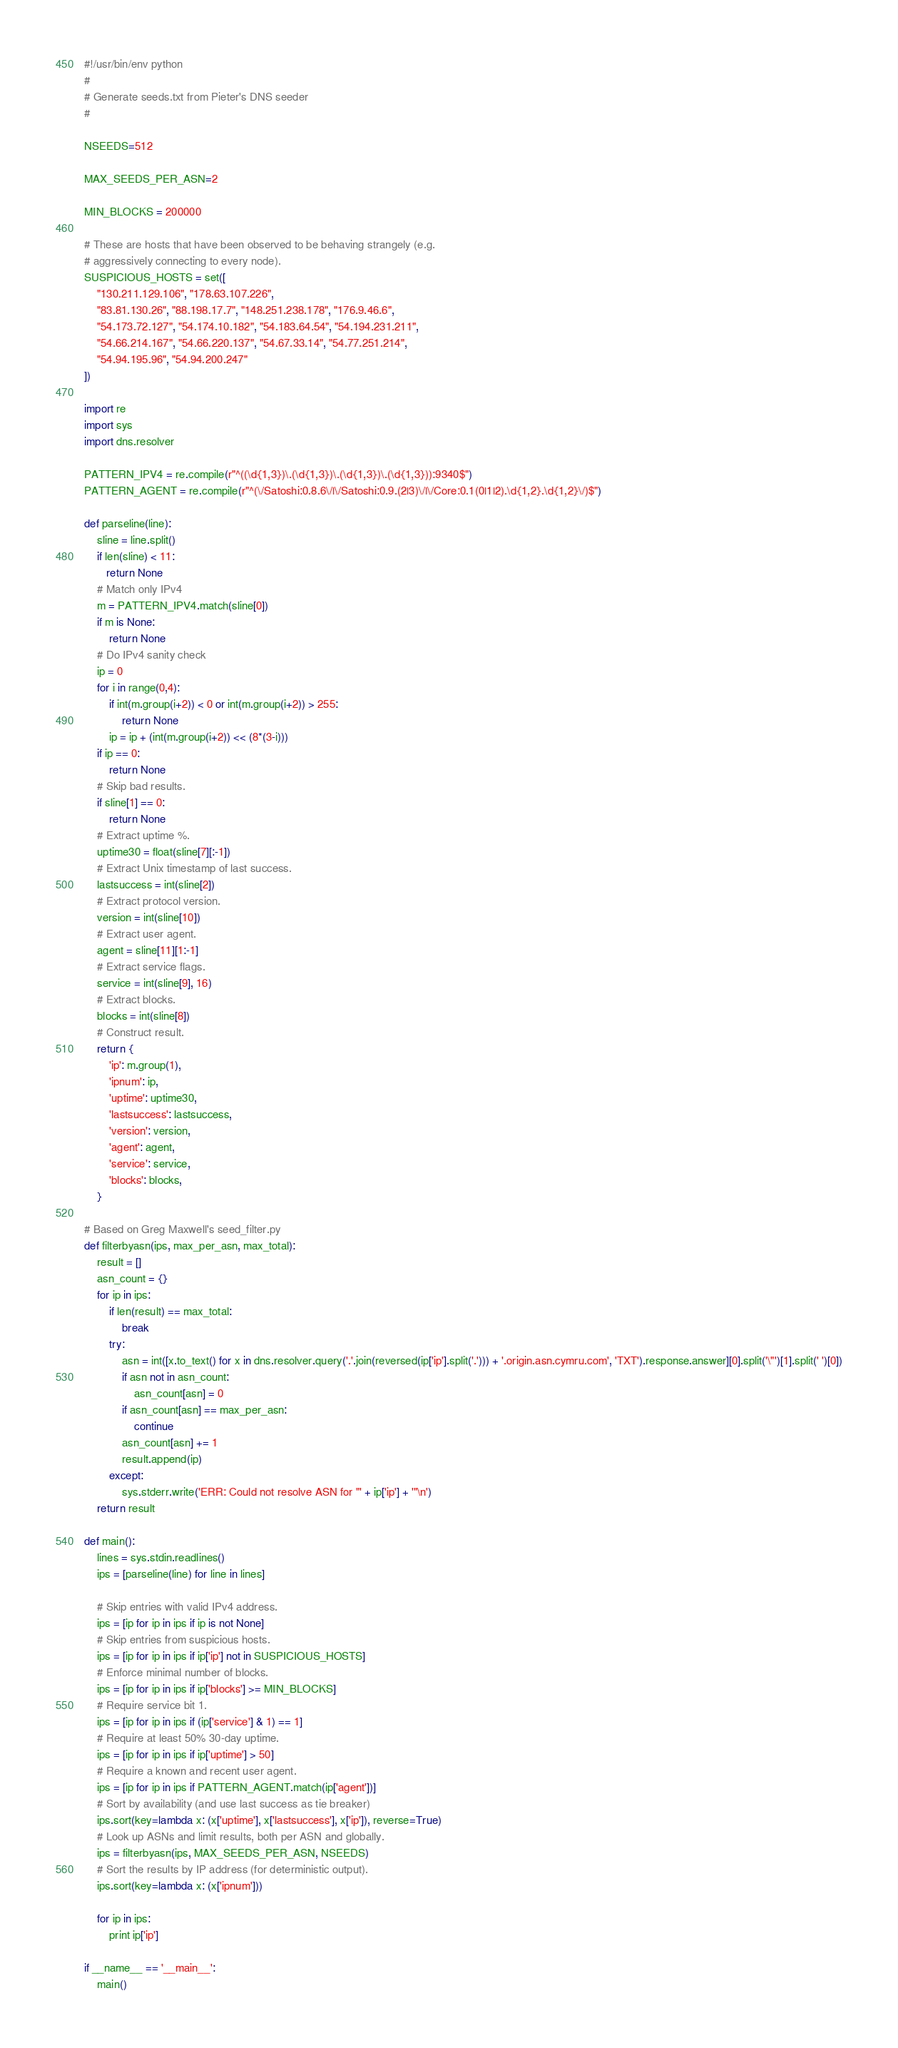Convert code to text. <code><loc_0><loc_0><loc_500><loc_500><_Python_>#!/usr/bin/env python
#
# Generate seeds.txt from Pieter's DNS seeder
#

NSEEDS=512

MAX_SEEDS_PER_ASN=2

MIN_BLOCKS = 200000

# These are hosts that have been observed to be behaving strangely (e.g.
# aggressively connecting to every node).
SUSPICIOUS_HOSTS = set([
    "130.211.129.106", "178.63.107.226",
    "83.81.130.26", "88.198.17.7", "148.251.238.178", "176.9.46.6",
    "54.173.72.127", "54.174.10.182", "54.183.64.54", "54.194.231.211",
    "54.66.214.167", "54.66.220.137", "54.67.33.14", "54.77.251.214",
    "54.94.195.96", "54.94.200.247"
])

import re
import sys
import dns.resolver

PATTERN_IPV4 = re.compile(r"^((\d{1,3})\.(\d{1,3})\.(\d{1,3})\.(\d{1,3})):9340$")
PATTERN_AGENT = re.compile(r"^(\/Satoshi:0.8.6\/|\/Satoshi:0.9.(2|3)\/|\/Core:0.1(0|1|2).\d{1,2}.\d{1,2}\/)$")

def parseline(line):
    sline = line.split()
    if len(sline) < 11:
       return None
    # Match only IPv4
    m = PATTERN_IPV4.match(sline[0])
    if m is None:
        return None
    # Do IPv4 sanity check
    ip = 0
    for i in range(0,4):
        if int(m.group(i+2)) < 0 or int(m.group(i+2)) > 255:
            return None
        ip = ip + (int(m.group(i+2)) << (8*(3-i)))
    if ip == 0:
        return None
    # Skip bad results.
    if sline[1] == 0:
        return None
    # Extract uptime %.
    uptime30 = float(sline[7][:-1])
    # Extract Unix timestamp of last success.
    lastsuccess = int(sline[2])
    # Extract protocol version.
    version = int(sline[10])
    # Extract user agent.
    agent = sline[11][1:-1]
    # Extract service flags.
    service = int(sline[9], 16)
    # Extract blocks.
    blocks = int(sline[8])
    # Construct result.
    return {
        'ip': m.group(1),
        'ipnum': ip,
        'uptime': uptime30,
        'lastsuccess': lastsuccess,
        'version': version,
        'agent': agent,
        'service': service,
        'blocks': blocks,
    }

# Based on Greg Maxwell's seed_filter.py
def filterbyasn(ips, max_per_asn, max_total):
    result = []
    asn_count = {}
    for ip in ips:
        if len(result) == max_total:
            break
        try:
            asn = int([x.to_text() for x in dns.resolver.query('.'.join(reversed(ip['ip'].split('.'))) + '.origin.asn.cymru.com', 'TXT').response.answer][0].split('\"')[1].split(' ')[0])
            if asn not in asn_count:
                asn_count[asn] = 0
            if asn_count[asn] == max_per_asn:
                continue
            asn_count[asn] += 1
            result.append(ip)
        except:
            sys.stderr.write('ERR: Could not resolve ASN for "' + ip['ip'] + '"\n')
    return result

def main():
    lines = sys.stdin.readlines()
    ips = [parseline(line) for line in lines]

    # Skip entries with valid IPv4 address.
    ips = [ip for ip in ips if ip is not None]
    # Skip entries from suspicious hosts.
    ips = [ip for ip in ips if ip['ip'] not in SUSPICIOUS_HOSTS]
    # Enforce minimal number of blocks.
    ips = [ip for ip in ips if ip['blocks'] >= MIN_BLOCKS]
    # Require service bit 1.
    ips = [ip for ip in ips if (ip['service'] & 1) == 1]
    # Require at least 50% 30-day uptime.
    ips = [ip for ip in ips if ip['uptime'] > 50]
    # Require a known and recent user agent.
    ips = [ip for ip in ips if PATTERN_AGENT.match(ip['agent'])]
    # Sort by availability (and use last success as tie breaker)
    ips.sort(key=lambda x: (x['uptime'], x['lastsuccess'], x['ip']), reverse=True)
    # Look up ASNs and limit results, both per ASN and globally.
    ips = filterbyasn(ips, MAX_SEEDS_PER_ASN, NSEEDS)
    # Sort the results by IP address (for deterministic output).
    ips.sort(key=lambda x: (x['ipnum']))

    for ip in ips:
        print ip['ip']

if __name__ == '__main__':
    main()
</code> 